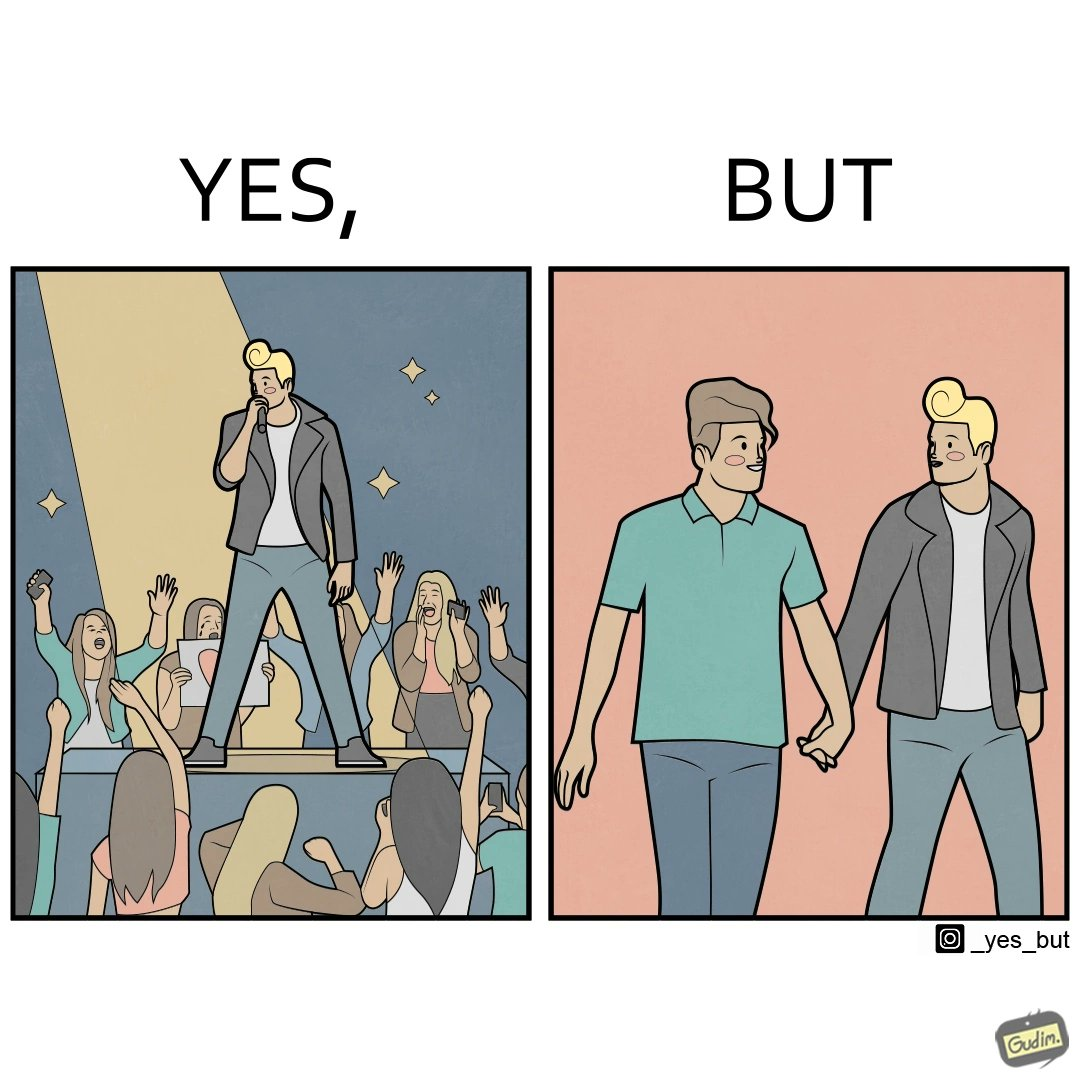Explain why this image is satirical. The image is funny because while the girls loves the man, he likes other men instead of women. 